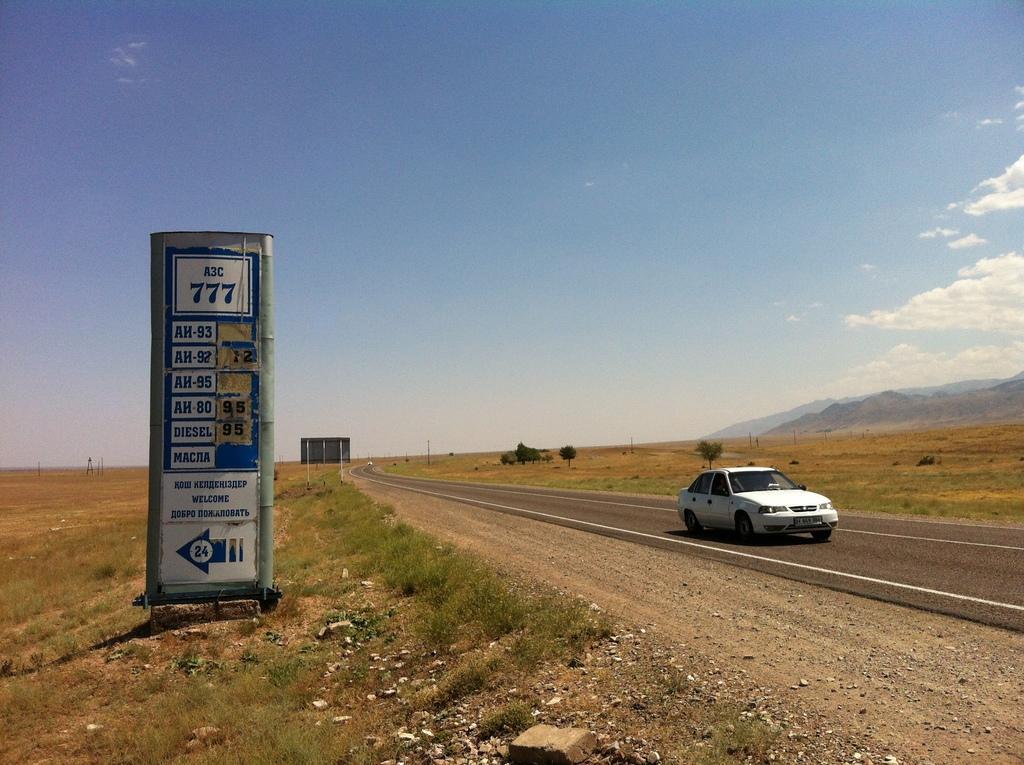Could you give a brief overview of what you see in this image? In this image I can see the ground, some grass on the ground, a board which is white and blue in color, few stones and the road. I can see a white colored car on the road and another board. In the background I can see few trees, few mountains, few poles and the sky. 